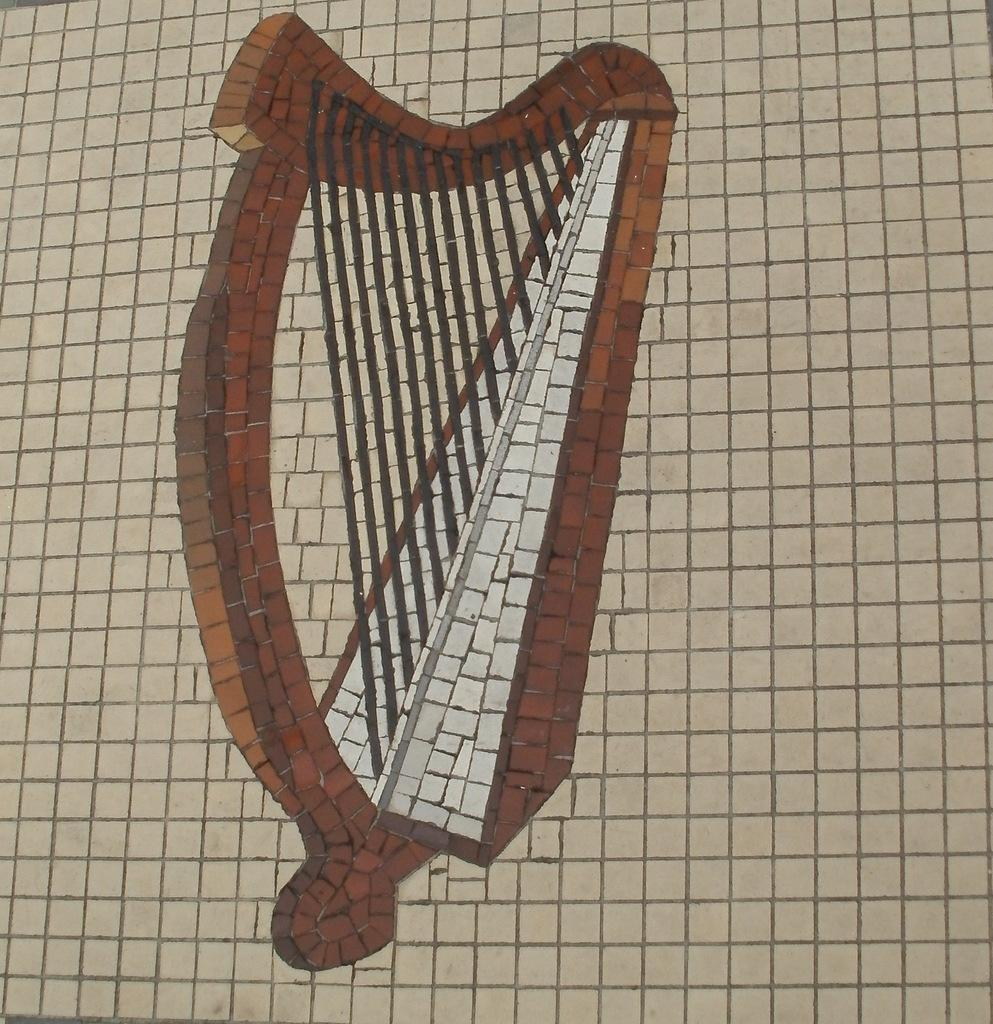What is the main subject of the image? There is a picture of a musical instrument in the image. What letter is being shaken in the image? There is no letter present in the image, and no shaking is depicted. The image only contains a picture of a musical instrument. 